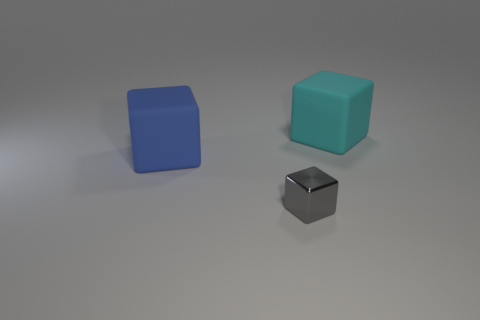Are the object that is behind the blue rubber object and the big blue cube made of the same material?
Provide a short and direct response. Yes. What color is the big cube behind the blue matte thing?
Offer a very short reply. Cyan. Is there a blue ball that has the same size as the cyan rubber object?
Offer a very short reply. No. There is a cube that is the same size as the cyan rubber thing; what is its material?
Your response must be concise. Rubber. There is a gray cube; does it have the same size as the object behind the blue thing?
Your response must be concise. No. What material is the big object in front of the big cyan block?
Ensure brevity in your answer.  Rubber. Are there the same number of gray objects that are behind the blue matte object and tiny objects?
Offer a terse response. No. Is the cyan matte object the same size as the gray thing?
Ensure brevity in your answer.  No. There is a large matte block in front of the large thing behind the blue cube; is there a tiny gray object that is behind it?
Provide a short and direct response. No. There is a gray thing that is the same shape as the big blue rubber object; what material is it?
Ensure brevity in your answer.  Metal. 